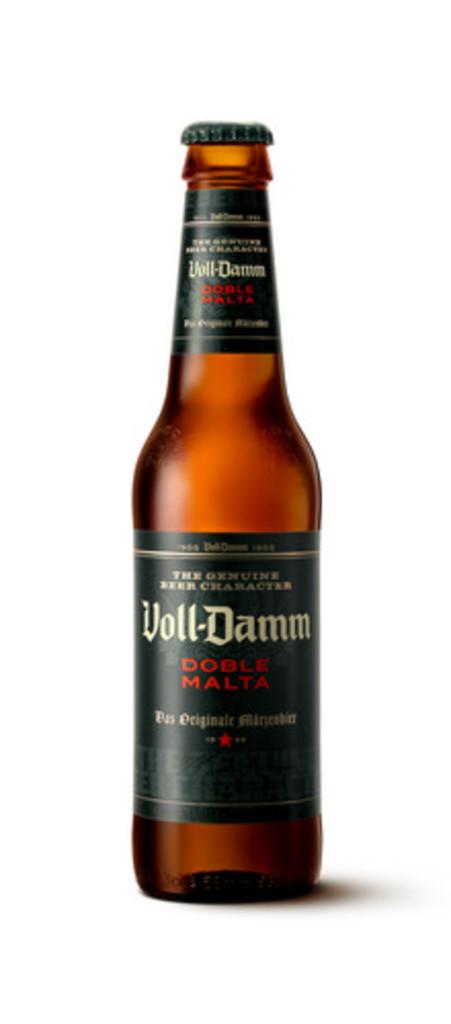What is the brand of beer?
Make the answer very short. Voll-damm. What do the words in red say?
Make the answer very short. Doble malta. 